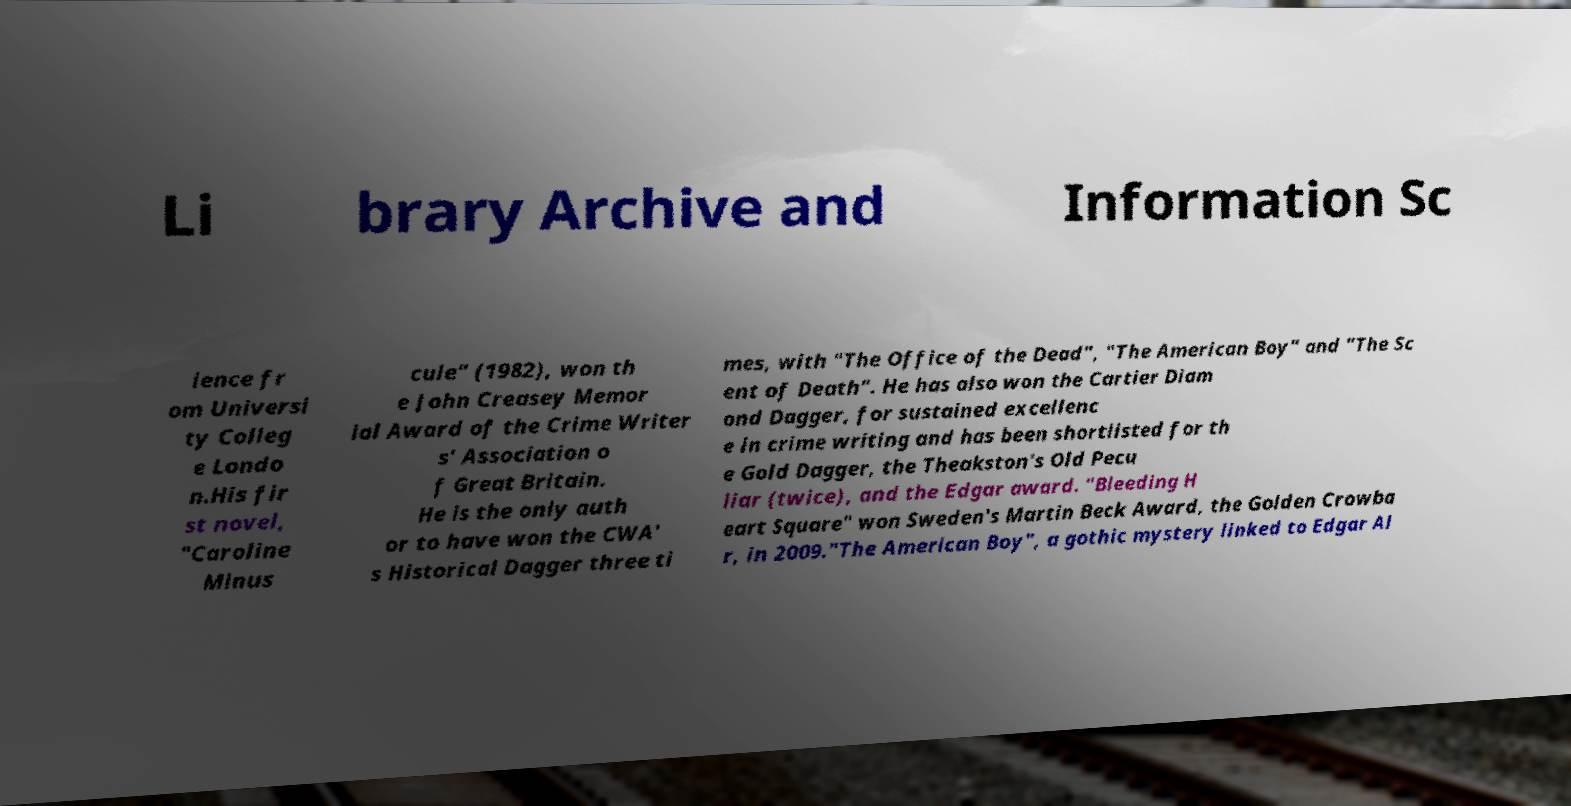There's text embedded in this image that I need extracted. Can you transcribe it verbatim? Li brary Archive and Information Sc ience fr om Universi ty Colleg e Londo n.His fir st novel, "Caroline Minus cule" (1982), won th e John Creasey Memor ial Award of the Crime Writer s' Association o f Great Britain. He is the only auth or to have won the CWA' s Historical Dagger three ti mes, with "The Office of the Dead", "The American Boy" and "The Sc ent of Death". He has also won the Cartier Diam ond Dagger, for sustained excellenc e in crime writing and has been shortlisted for th e Gold Dagger, the Theakston's Old Pecu liar (twice), and the Edgar award. "Bleeding H eart Square" won Sweden's Martin Beck Award, the Golden Crowba r, in 2009."The American Boy", a gothic mystery linked to Edgar Al 